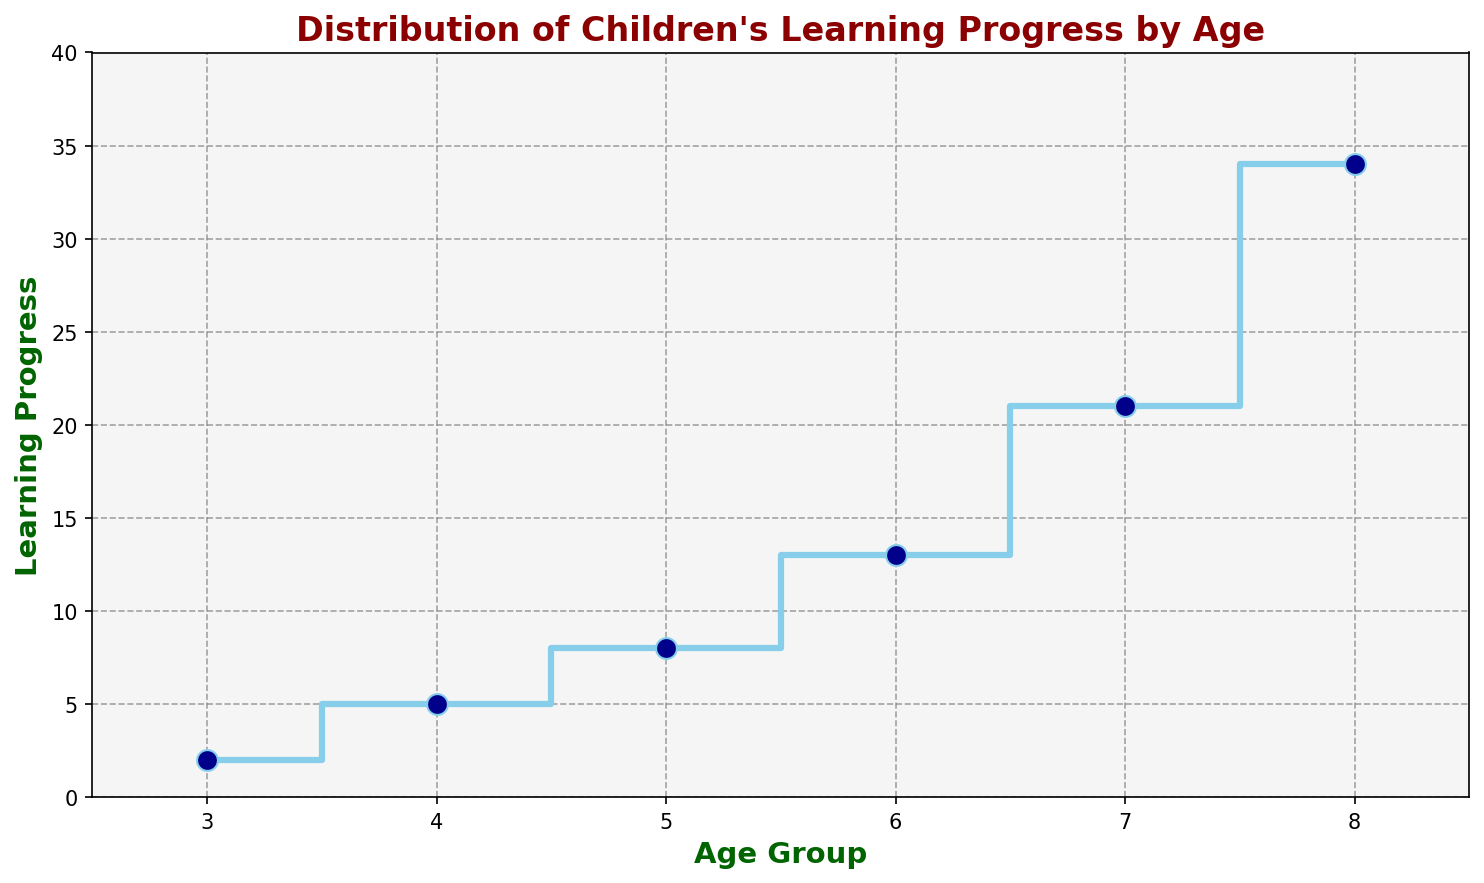What age group shows the greatest learning progress? The figure shows the learning progress for different age groups with the stair steps. The age group with the highest step value indicates the greatest learning progress. From the plot, the age group of 8 has the steepest and highest step, indicating the greatest learning progress.
Answer: 8 Compare the learning progress between the age groups of 5 and 7. Which age group has shown a higher increase? To compare the learning progress, observe the values at ages 5 and 7. At age 5, the progress is 8, and at age 7, it’s 21. The increase from age 5 to 7 is 21 - 8 = 13. Therefore, the age group of 7 shows a higher increase compared to 5.
Answer: 7 What is the difference in learning progress between the youngest and oldest age groups? The youngest age group is 3 years with a progress value of 2, and the oldest age group is 8 years with a progress value of 34. The difference is calculated as 34 - 2 = 32.
Answer: 32 At what age group does the learning progress start to rise significantly faster than in the previous age groups? Analyzing the stairs plot, we note a significant increase in the learning progress when the stair steps become higher and more vertical. This significant rise happens between age 6 and age 7, from 13 to 21.
Answer: 7 Identify the age group where the learning progress is exactly halfway between the lowest and highest learning progress values. The lowest progress is 2 at age 3, and the highest is 34 at age 8. Halfway between 2 and 34 is (2 + 34) / 2 = 18. The value closest to 18 in the plot is at age 7 with a progress value of 21.
Answer: 7 Which age group has seen a doubling in their learning progress in comparison to an age group 3 years younger? To find this, compare each age group with those 3 years younger. For instance, age 6 (progress 13) is more than double age 3 (progress 2), age 7 (progress 21) compares to age 4 (progress 5), and age 8 (progress 34) compares to age 5 (progress 8). Age 8, with progression more than doubling that of age 5.
Answer: 8 What could we infer about learning curves based on the plot color and style representation? The plot uses a step representation emphasized by a skyblue color and highlighted markers, indicating progressive and cumulative learning steps in sensorial activities, providing distinct clarity for each age group’s progress.
Answer: Visual clarity and progression 